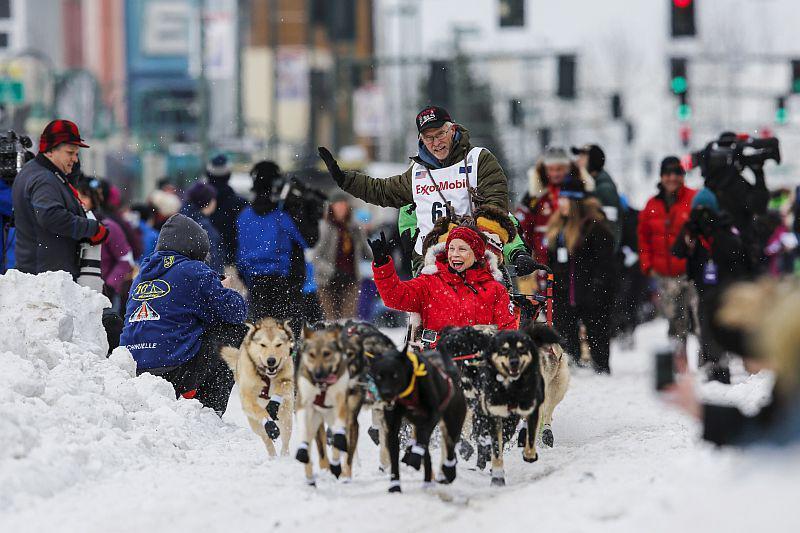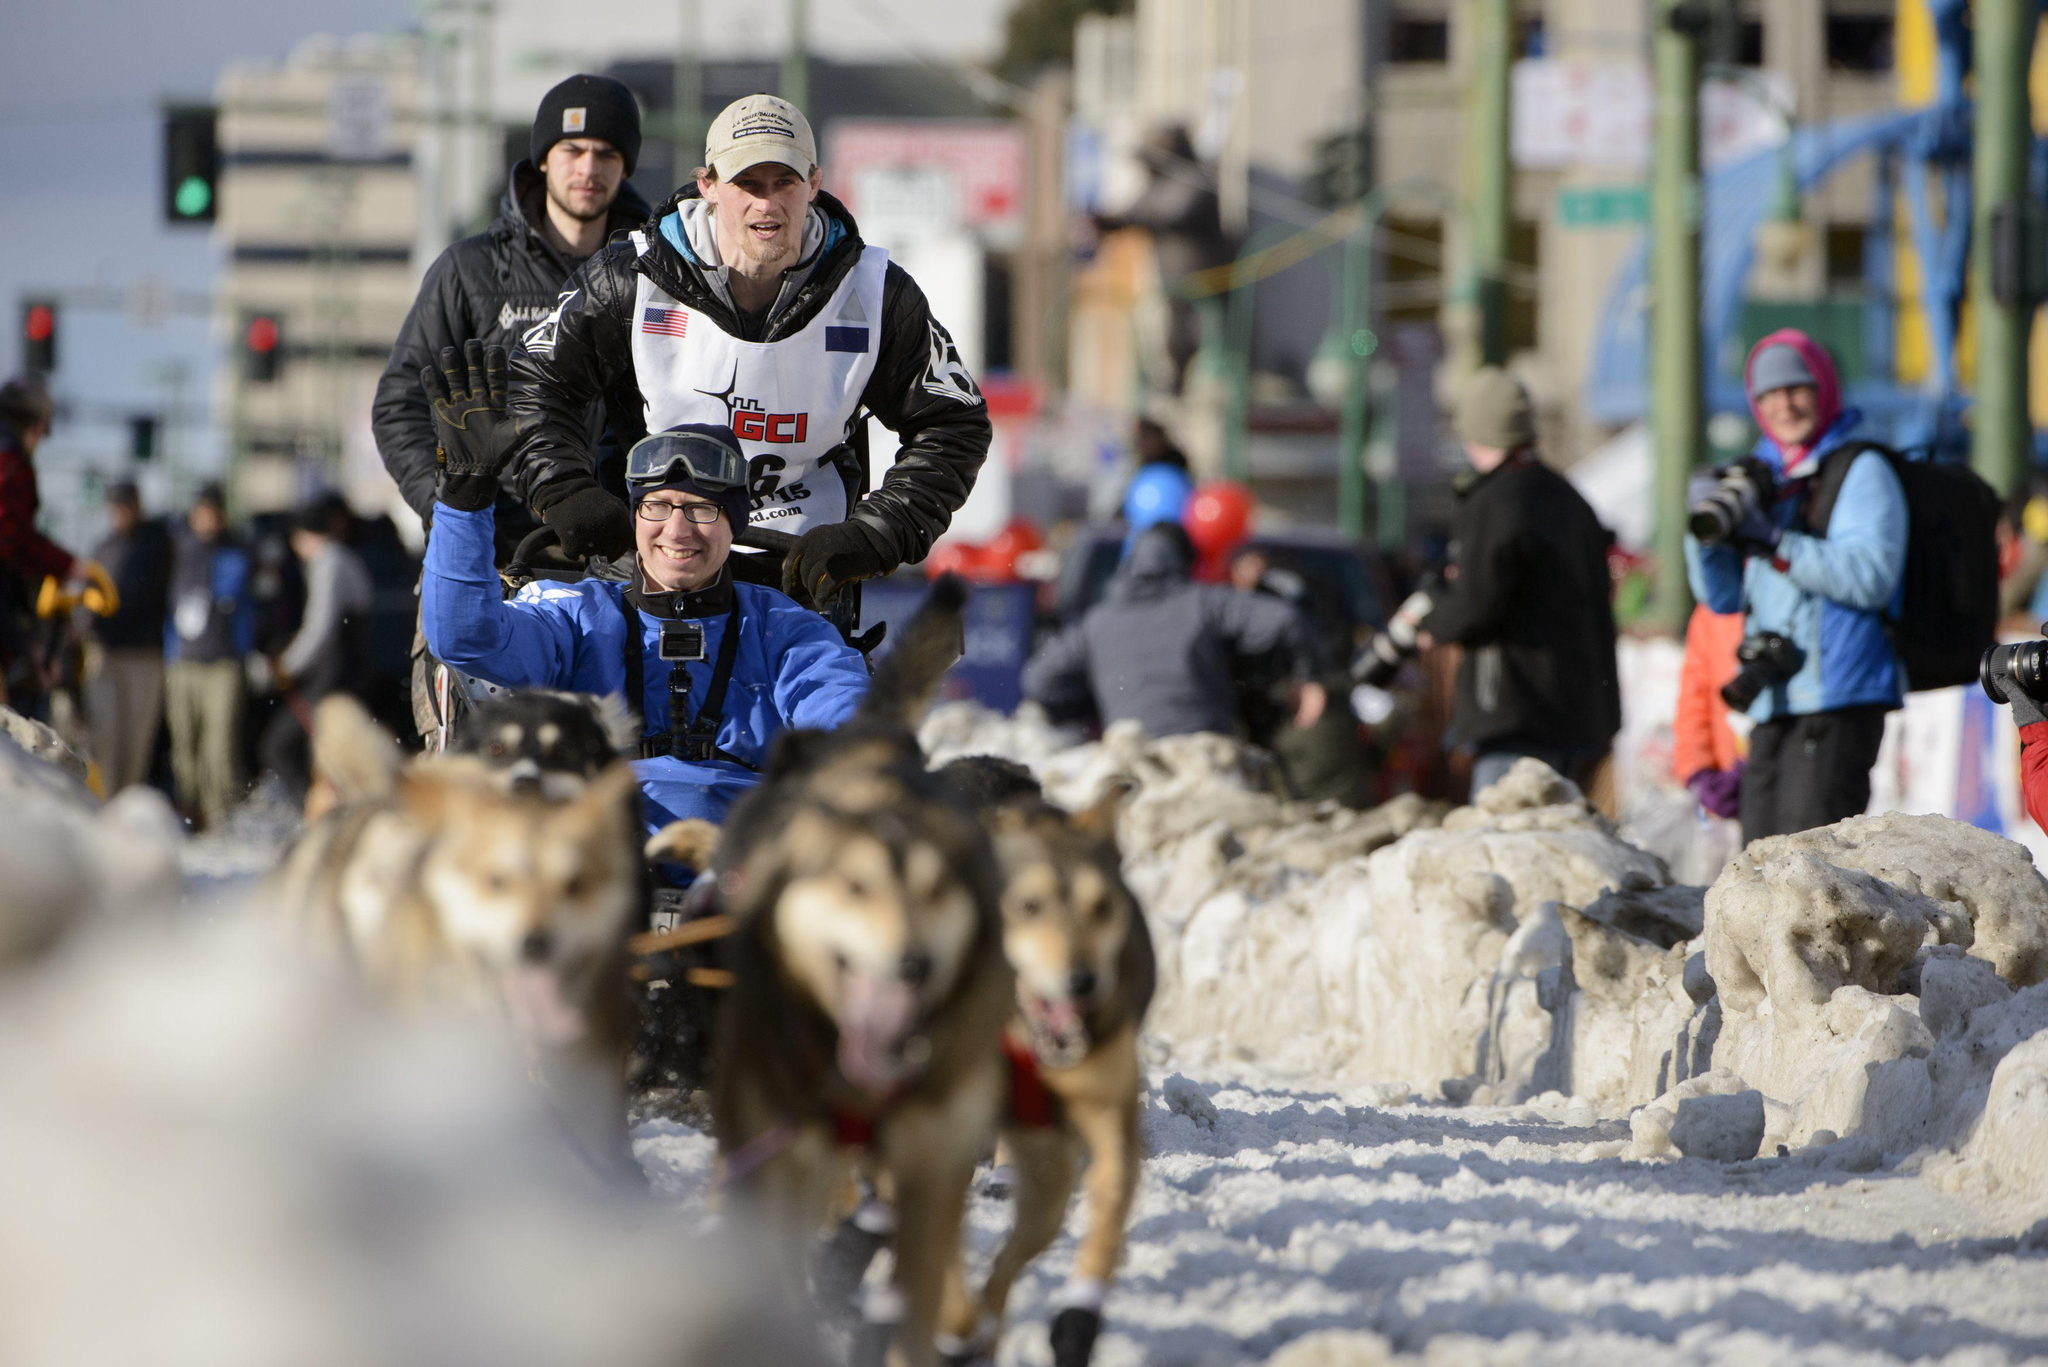The first image is the image on the left, the second image is the image on the right. Assess this claim about the two images: "A person riding the sled is waving.". Correct or not? Answer yes or no. Yes. 